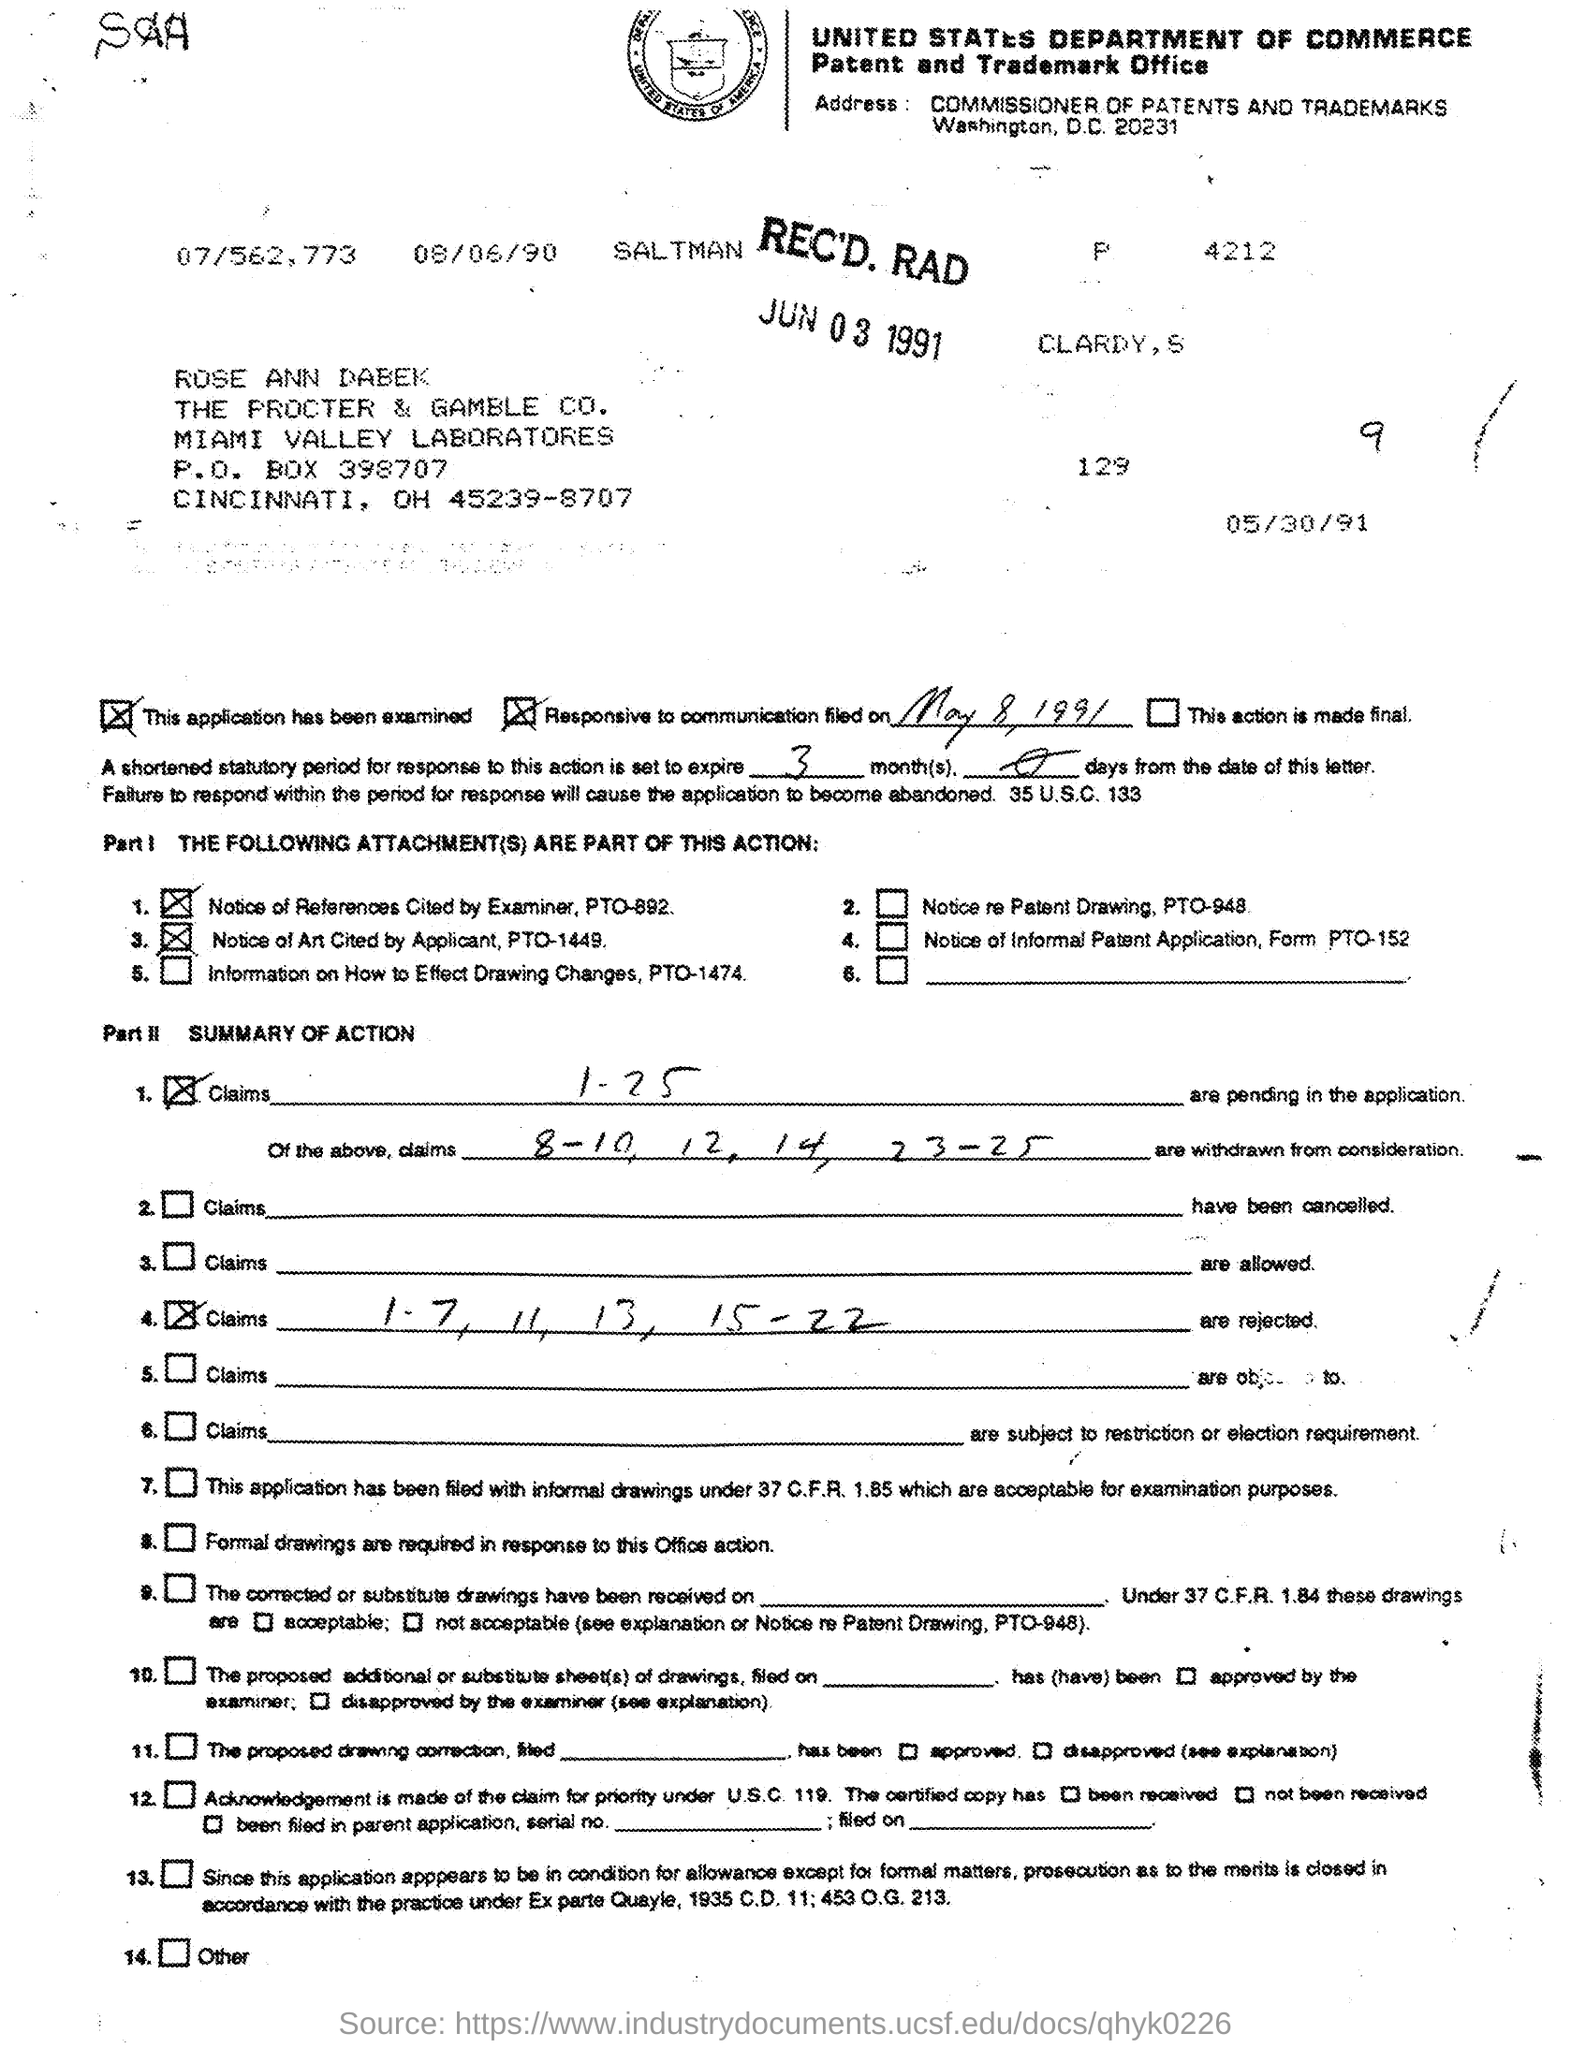When did the communication filed on?
Your answer should be very brief. May 8, 1991. 